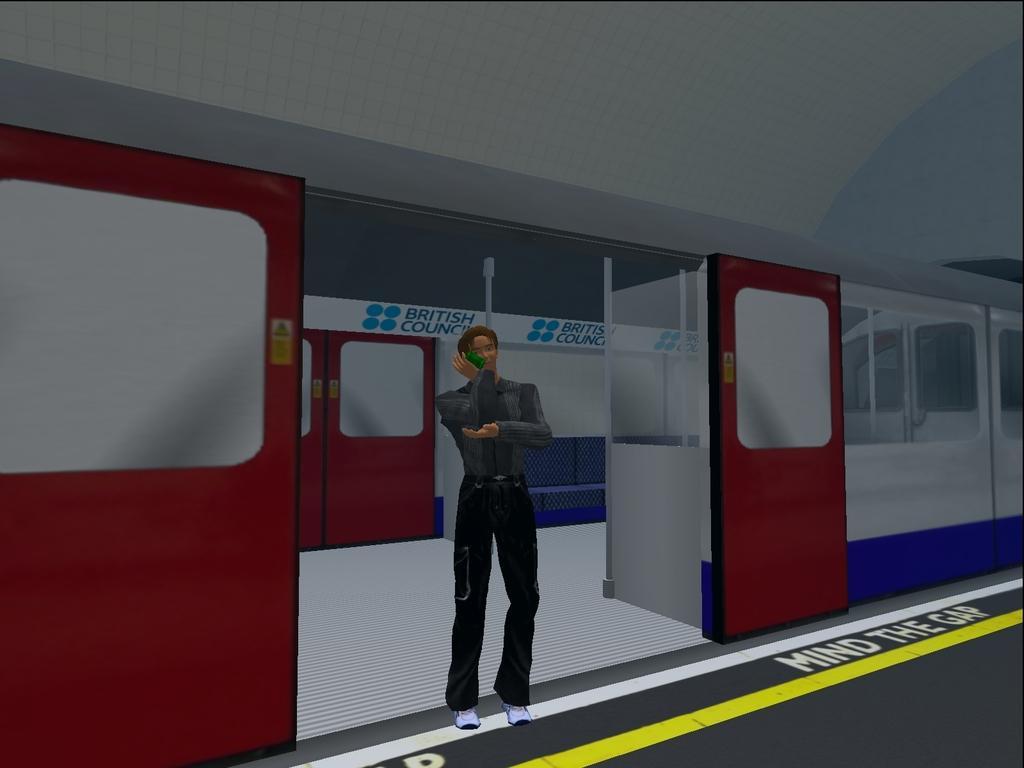Describe this image in one or two sentences. In this picture there is a poster in the center of the image, on which there is a train and a man. 